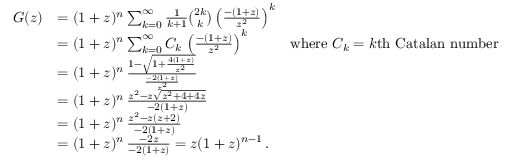Convert formula to latex. <formula><loc_0><loc_0><loc_500><loc_500>{ \begin{array} { r l r } { G ( z ) } & { = ( 1 + z ) ^ { n } \sum _ { k = 0 } ^ { \infty } { \frac { 1 } { k + 1 } } { \binom { 2 k } { k } } \left ( { \frac { - ( 1 + z ) } { z ^ { 2 } } } \right ) ^ { k } } \\ & { = ( 1 + z ) ^ { n } \sum _ { k = 0 } ^ { \infty } C _ { k } \, \left ( { \frac { - ( 1 + z ) } { z ^ { 2 } } } \right ) ^ { k } } & { { w h e r e } C _ { k } = k { t h C a t a l a n n u m b e r } } \\ & { = ( 1 + z ) ^ { n } \, { \frac { 1 - { \sqrt { 1 + { \frac { 4 ( 1 + z ) } { z ^ { 2 } } } } } } { \frac { - 2 ( 1 + z ) } { z ^ { 2 } } } } } \\ & { = ( 1 + z ) ^ { n } \, { \frac { z ^ { 2 } - z { \sqrt { z ^ { 2 } + 4 + 4 z } } } { - 2 ( 1 + z ) } } } \\ & { = ( 1 + z ) ^ { n } \, { \frac { z ^ { 2 } - z ( z + 2 ) } { - 2 ( 1 + z ) } } } \\ & { = ( 1 + z ) ^ { n } \, { \frac { - 2 z } { - 2 ( 1 + z ) } } = z ( 1 + z ) ^ { n - 1 } \, . } \end{array} }</formula> 